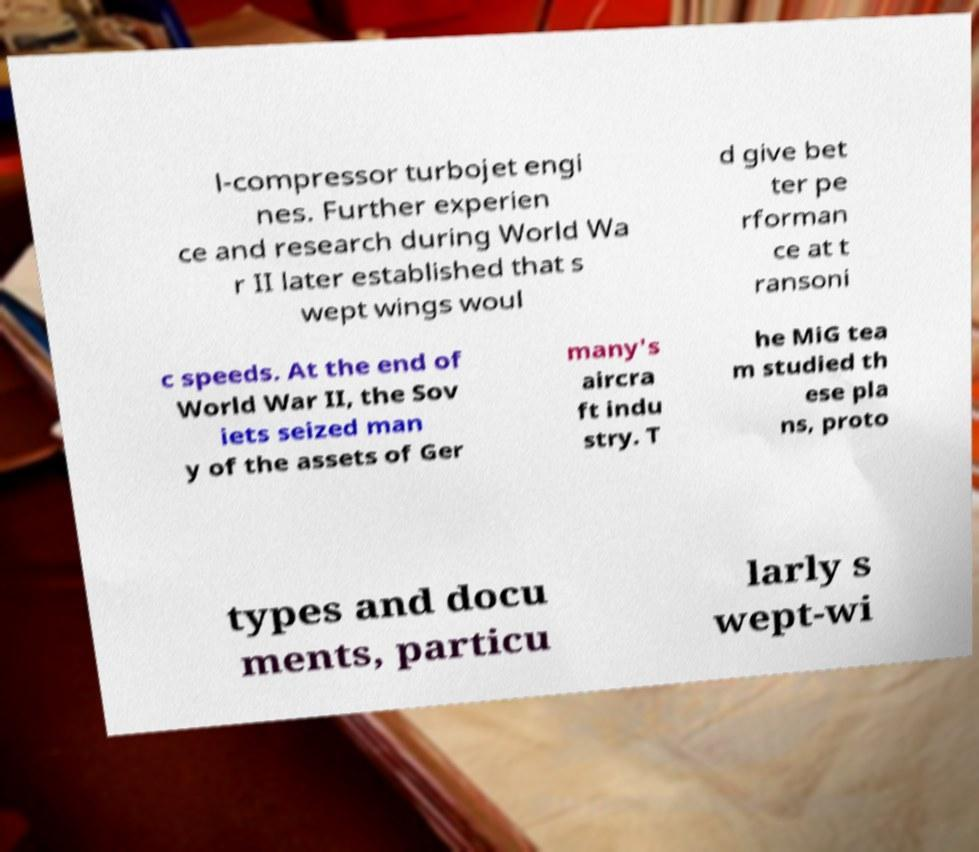Can you read and provide the text displayed in the image?This photo seems to have some interesting text. Can you extract and type it out for me? l-compressor turbojet engi nes. Further experien ce and research during World Wa r II later established that s wept wings woul d give bet ter pe rforman ce at t ransoni c speeds. At the end of World War II, the Sov iets seized man y of the assets of Ger many's aircra ft indu stry. T he MiG tea m studied th ese pla ns, proto types and docu ments, particu larly s wept-wi 